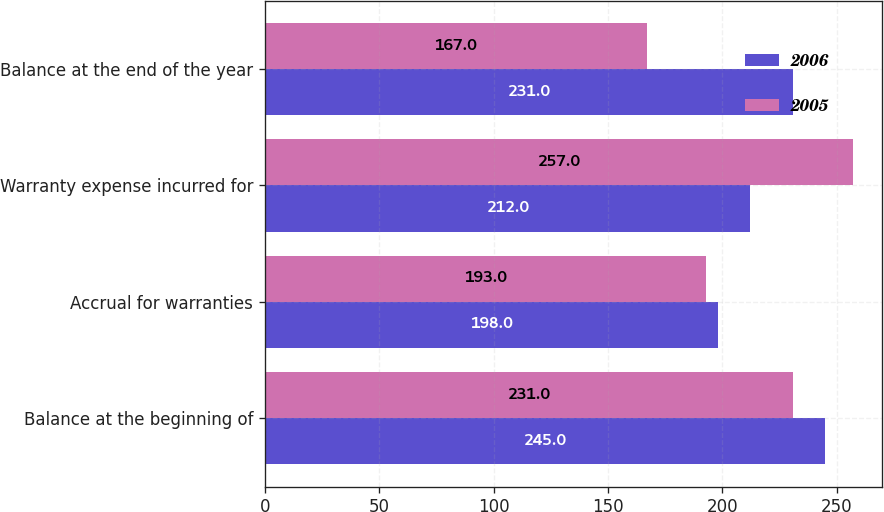Convert chart. <chart><loc_0><loc_0><loc_500><loc_500><stacked_bar_chart><ecel><fcel>Balance at the beginning of<fcel>Accrual for warranties<fcel>Warranty expense incurred for<fcel>Balance at the end of the year<nl><fcel>2006<fcel>245<fcel>198<fcel>212<fcel>231<nl><fcel>2005<fcel>231<fcel>193<fcel>257<fcel>167<nl></chart> 